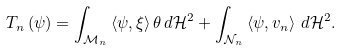<formula> <loc_0><loc_0><loc_500><loc_500>T _ { n } \left ( \psi \right ) = \int _ { \mathcal { M } _ { n } } \left \langle \psi , \xi \right \rangle \theta \, d \mathcal { H } ^ { 2 } + \int _ { \mathcal { N } _ { n } } \left \langle \psi , v _ { n } \right \rangle \, d \mathcal { H } ^ { 2 } .</formula> 